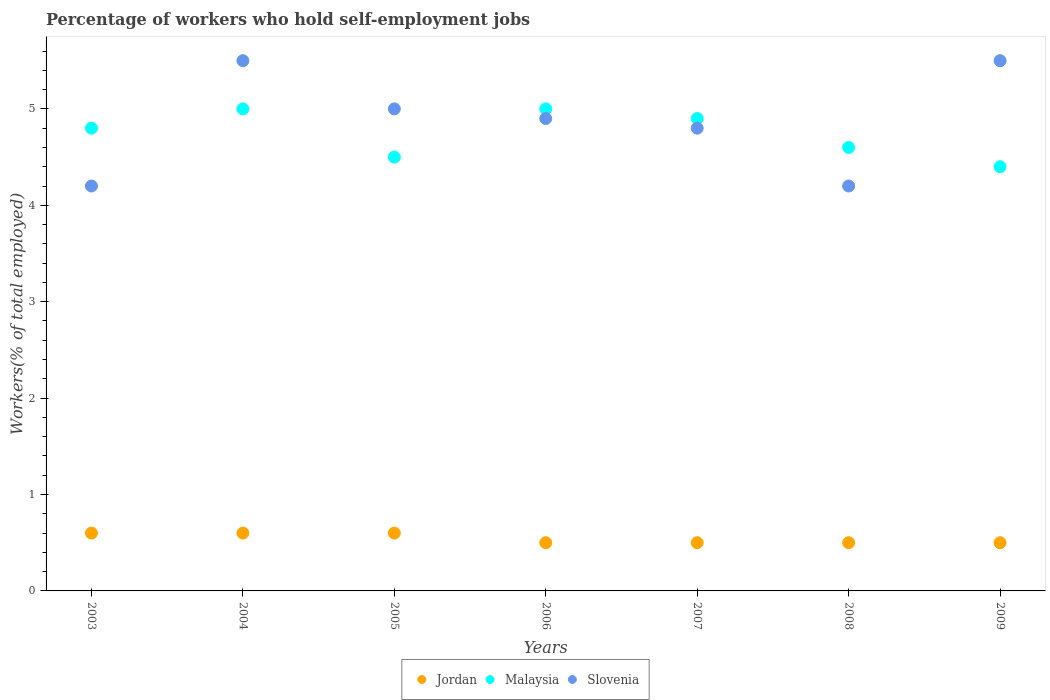How many different coloured dotlines are there?
Offer a very short reply. 3. Is the number of dotlines equal to the number of legend labels?
Offer a very short reply. Yes. What is the percentage of self-employed workers in Slovenia in 2007?
Give a very brief answer. 4.8. Across all years, what is the maximum percentage of self-employed workers in Malaysia?
Ensure brevity in your answer.  5. Across all years, what is the minimum percentage of self-employed workers in Jordan?
Keep it short and to the point. 0.5. In which year was the percentage of self-employed workers in Jordan maximum?
Give a very brief answer. 2003. In which year was the percentage of self-employed workers in Jordan minimum?
Ensure brevity in your answer.  2006. What is the total percentage of self-employed workers in Jordan in the graph?
Provide a short and direct response. 3.8. What is the difference between the percentage of self-employed workers in Slovenia in 2005 and that in 2008?
Offer a very short reply. 0.8. What is the average percentage of self-employed workers in Slovenia per year?
Ensure brevity in your answer.  4.87. In the year 2004, what is the difference between the percentage of self-employed workers in Slovenia and percentage of self-employed workers in Jordan?
Give a very brief answer. 4.9. What is the ratio of the percentage of self-employed workers in Slovenia in 2007 to that in 2009?
Offer a very short reply. 0.87. Is the difference between the percentage of self-employed workers in Slovenia in 2005 and 2009 greater than the difference between the percentage of self-employed workers in Jordan in 2005 and 2009?
Your answer should be compact. No. What is the difference between the highest and the lowest percentage of self-employed workers in Jordan?
Your response must be concise. 0.1. Is the sum of the percentage of self-employed workers in Jordan in 2003 and 2004 greater than the maximum percentage of self-employed workers in Malaysia across all years?
Give a very brief answer. No. Does the percentage of self-employed workers in Malaysia monotonically increase over the years?
Offer a very short reply. No. Is the percentage of self-employed workers in Malaysia strictly less than the percentage of self-employed workers in Jordan over the years?
Offer a terse response. No. How many years are there in the graph?
Offer a very short reply. 7. Does the graph contain grids?
Ensure brevity in your answer.  No. How are the legend labels stacked?
Offer a very short reply. Horizontal. What is the title of the graph?
Offer a terse response. Percentage of workers who hold self-employment jobs. What is the label or title of the Y-axis?
Make the answer very short. Workers(% of total employed). What is the Workers(% of total employed) in Jordan in 2003?
Keep it short and to the point. 0.6. What is the Workers(% of total employed) of Malaysia in 2003?
Give a very brief answer. 4.8. What is the Workers(% of total employed) of Slovenia in 2003?
Your response must be concise. 4.2. What is the Workers(% of total employed) of Jordan in 2004?
Ensure brevity in your answer.  0.6. What is the Workers(% of total employed) in Slovenia in 2004?
Your answer should be very brief. 5.5. What is the Workers(% of total employed) of Jordan in 2005?
Ensure brevity in your answer.  0.6. What is the Workers(% of total employed) in Malaysia in 2005?
Offer a terse response. 4.5. What is the Workers(% of total employed) in Jordan in 2006?
Provide a succinct answer. 0.5. What is the Workers(% of total employed) of Slovenia in 2006?
Make the answer very short. 4.9. What is the Workers(% of total employed) in Jordan in 2007?
Your response must be concise. 0.5. What is the Workers(% of total employed) in Malaysia in 2007?
Offer a terse response. 4.9. What is the Workers(% of total employed) in Slovenia in 2007?
Provide a succinct answer. 4.8. What is the Workers(% of total employed) in Jordan in 2008?
Make the answer very short. 0.5. What is the Workers(% of total employed) of Malaysia in 2008?
Ensure brevity in your answer.  4.6. What is the Workers(% of total employed) in Slovenia in 2008?
Offer a terse response. 4.2. What is the Workers(% of total employed) of Jordan in 2009?
Make the answer very short. 0.5. What is the Workers(% of total employed) in Malaysia in 2009?
Provide a short and direct response. 4.4. What is the Workers(% of total employed) of Slovenia in 2009?
Your answer should be compact. 5.5. Across all years, what is the maximum Workers(% of total employed) of Jordan?
Give a very brief answer. 0.6. Across all years, what is the maximum Workers(% of total employed) of Malaysia?
Your answer should be very brief. 5. Across all years, what is the minimum Workers(% of total employed) in Malaysia?
Provide a succinct answer. 4.4. Across all years, what is the minimum Workers(% of total employed) of Slovenia?
Your answer should be very brief. 4.2. What is the total Workers(% of total employed) of Jordan in the graph?
Provide a short and direct response. 3.8. What is the total Workers(% of total employed) in Malaysia in the graph?
Ensure brevity in your answer.  33.2. What is the total Workers(% of total employed) of Slovenia in the graph?
Offer a terse response. 34.1. What is the difference between the Workers(% of total employed) of Slovenia in 2003 and that in 2004?
Provide a succinct answer. -1.3. What is the difference between the Workers(% of total employed) of Malaysia in 2003 and that in 2005?
Your answer should be compact. 0.3. What is the difference between the Workers(% of total employed) of Slovenia in 2003 and that in 2005?
Provide a succinct answer. -0.8. What is the difference between the Workers(% of total employed) of Malaysia in 2003 and that in 2006?
Provide a short and direct response. -0.2. What is the difference between the Workers(% of total employed) in Malaysia in 2003 and that in 2007?
Keep it short and to the point. -0.1. What is the difference between the Workers(% of total employed) of Slovenia in 2003 and that in 2007?
Your answer should be compact. -0.6. What is the difference between the Workers(% of total employed) in Jordan in 2003 and that in 2008?
Offer a terse response. 0.1. What is the difference between the Workers(% of total employed) in Slovenia in 2003 and that in 2008?
Make the answer very short. 0. What is the difference between the Workers(% of total employed) in Jordan in 2003 and that in 2009?
Keep it short and to the point. 0.1. What is the difference between the Workers(% of total employed) of Jordan in 2004 and that in 2005?
Your response must be concise. 0. What is the difference between the Workers(% of total employed) of Malaysia in 2004 and that in 2005?
Offer a terse response. 0.5. What is the difference between the Workers(% of total employed) of Slovenia in 2004 and that in 2005?
Ensure brevity in your answer.  0.5. What is the difference between the Workers(% of total employed) of Jordan in 2004 and that in 2006?
Offer a terse response. 0.1. What is the difference between the Workers(% of total employed) of Slovenia in 2004 and that in 2006?
Ensure brevity in your answer.  0.6. What is the difference between the Workers(% of total employed) of Jordan in 2004 and that in 2007?
Provide a short and direct response. 0.1. What is the difference between the Workers(% of total employed) in Slovenia in 2004 and that in 2007?
Make the answer very short. 0.7. What is the difference between the Workers(% of total employed) in Jordan in 2004 and that in 2009?
Make the answer very short. 0.1. What is the difference between the Workers(% of total employed) in Malaysia in 2004 and that in 2009?
Ensure brevity in your answer.  0.6. What is the difference between the Workers(% of total employed) of Jordan in 2005 and that in 2006?
Offer a terse response. 0.1. What is the difference between the Workers(% of total employed) of Slovenia in 2005 and that in 2006?
Your answer should be compact. 0.1. What is the difference between the Workers(% of total employed) in Jordan in 2005 and that in 2008?
Offer a terse response. 0.1. What is the difference between the Workers(% of total employed) of Jordan in 2005 and that in 2009?
Offer a terse response. 0.1. What is the difference between the Workers(% of total employed) of Malaysia in 2005 and that in 2009?
Give a very brief answer. 0.1. What is the difference between the Workers(% of total employed) in Jordan in 2007 and that in 2008?
Offer a very short reply. 0. What is the difference between the Workers(% of total employed) of Jordan in 2007 and that in 2009?
Your response must be concise. 0. What is the difference between the Workers(% of total employed) in Slovenia in 2007 and that in 2009?
Provide a short and direct response. -0.7. What is the difference between the Workers(% of total employed) of Malaysia in 2008 and that in 2009?
Provide a short and direct response. 0.2. What is the difference between the Workers(% of total employed) in Jordan in 2003 and the Workers(% of total employed) in Malaysia in 2004?
Provide a short and direct response. -4.4. What is the difference between the Workers(% of total employed) of Jordan in 2003 and the Workers(% of total employed) of Malaysia in 2005?
Offer a very short reply. -3.9. What is the difference between the Workers(% of total employed) in Jordan in 2003 and the Workers(% of total employed) in Slovenia in 2006?
Ensure brevity in your answer.  -4.3. What is the difference between the Workers(% of total employed) of Malaysia in 2003 and the Workers(% of total employed) of Slovenia in 2006?
Provide a short and direct response. -0.1. What is the difference between the Workers(% of total employed) in Jordan in 2003 and the Workers(% of total employed) in Malaysia in 2007?
Offer a very short reply. -4.3. What is the difference between the Workers(% of total employed) of Jordan in 2003 and the Workers(% of total employed) of Malaysia in 2008?
Offer a very short reply. -4. What is the difference between the Workers(% of total employed) in Jordan in 2003 and the Workers(% of total employed) in Slovenia in 2008?
Keep it short and to the point. -3.6. What is the difference between the Workers(% of total employed) in Malaysia in 2003 and the Workers(% of total employed) in Slovenia in 2008?
Provide a short and direct response. 0.6. What is the difference between the Workers(% of total employed) of Jordan in 2003 and the Workers(% of total employed) of Malaysia in 2009?
Make the answer very short. -3.8. What is the difference between the Workers(% of total employed) of Jordan in 2004 and the Workers(% of total employed) of Malaysia in 2005?
Make the answer very short. -3.9. What is the difference between the Workers(% of total employed) in Jordan in 2004 and the Workers(% of total employed) in Slovenia in 2005?
Your response must be concise. -4.4. What is the difference between the Workers(% of total employed) of Malaysia in 2004 and the Workers(% of total employed) of Slovenia in 2005?
Your response must be concise. 0. What is the difference between the Workers(% of total employed) in Jordan in 2004 and the Workers(% of total employed) in Malaysia in 2007?
Give a very brief answer. -4.3. What is the difference between the Workers(% of total employed) of Jordan in 2004 and the Workers(% of total employed) of Slovenia in 2007?
Your response must be concise. -4.2. What is the difference between the Workers(% of total employed) in Jordan in 2004 and the Workers(% of total employed) in Malaysia in 2008?
Make the answer very short. -4. What is the difference between the Workers(% of total employed) in Malaysia in 2004 and the Workers(% of total employed) in Slovenia in 2008?
Your answer should be compact. 0.8. What is the difference between the Workers(% of total employed) of Jordan in 2004 and the Workers(% of total employed) of Malaysia in 2009?
Provide a succinct answer. -3.8. What is the difference between the Workers(% of total employed) in Jordan in 2005 and the Workers(% of total employed) in Malaysia in 2006?
Your answer should be very brief. -4.4. What is the difference between the Workers(% of total employed) in Jordan in 2005 and the Workers(% of total employed) in Slovenia in 2006?
Keep it short and to the point. -4.3. What is the difference between the Workers(% of total employed) in Malaysia in 2005 and the Workers(% of total employed) in Slovenia in 2007?
Your response must be concise. -0.3. What is the difference between the Workers(% of total employed) in Jordan in 2005 and the Workers(% of total employed) in Slovenia in 2008?
Offer a very short reply. -3.6. What is the difference between the Workers(% of total employed) in Jordan in 2005 and the Workers(% of total employed) in Slovenia in 2009?
Provide a short and direct response. -4.9. What is the difference between the Workers(% of total employed) in Malaysia in 2005 and the Workers(% of total employed) in Slovenia in 2009?
Your response must be concise. -1. What is the difference between the Workers(% of total employed) in Jordan in 2006 and the Workers(% of total employed) in Malaysia in 2007?
Give a very brief answer. -4.4. What is the difference between the Workers(% of total employed) of Jordan in 2006 and the Workers(% of total employed) of Slovenia in 2007?
Keep it short and to the point. -4.3. What is the difference between the Workers(% of total employed) in Jordan in 2006 and the Workers(% of total employed) in Slovenia in 2008?
Give a very brief answer. -3.7. What is the difference between the Workers(% of total employed) in Malaysia in 2006 and the Workers(% of total employed) in Slovenia in 2008?
Your response must be concise. 0.8. What is the difference between the Workers(% of total employed) of Jordan in 2006 and the Workers(% of total employed) of Malaysia in 2009?
Offer a very short reply. -3.9. What is the difference between the Workers(% of total employed) of Jordan in 2006 and the Workers(% of total employed) of Slovenia in 2009?
Provide a succinct answer. -5. What is the difference between the Workers(% of total employed) of Jordan in 2007 and the Workers(% of total employed) of Malaysia in 2008?
Provide a short and direct response. -4.1. What is the difference between the Workers(% of total employed) of Malaysia in 2007 and the Workers(% of total employed) of Slovenia in 2008?
Offer a very short reply. 0.7. What is the difference between the Workers(% of total employed) in Jordan in 2007 and the Workers(% of total employed) in Malaysia in 2009?
Your answer should be compact. -3.9. What is the difference between the Workers(% of total employed) in Malaysia in 2007 and the Workers(% of total employed) in Slovenia in 2009?
Give a very brief answer. -0.6. What is the difference between the Workers(% of total employed) of Jordan in 2008 and the Workers(% of total employed) of Malaysia in 2009?
Ensure brevity in your answer.  -3.9. What is the difference between the Workers(% of total employed) of Malaysia in 2008 and the Workers(% of total employed) of Slovenia in 2009?
Keep it short and to the point. -0.9. What is the average Workers(% of total employed) of Jordan per year?
Your response must be concise. 0.54. What is the average Workers(% of total employed) of Malaysia per year?
Offer a very short reply. 4.74. What is the average Workers(% of total employed) in Slovenia per year?
Ensure brevity in your answer.  4.87. In the year 2003, what is the difference between the Workers(% of total employed) of Jordan and Workers(% of total employed) of Slovenia?
Keep it short and to the point. -3.6. In the year 2004, what is the difference between the Workers(% of total employed) of Malaysia and Workers(% of total employed) of Slovenia?
Offer a very short reply. -0.5. In the year 2005, what is the difference between the Workers(% of total employed) of Jordan and Workers(% of total employed) of Malaysia?
Keep it short and to the point. -3.9. In the year 2005, what is the difference between the Workers(% of total employed) in Jordan and Workers(% of total employed) in Slovenia?
Offer a very short reply. -4.4. In the year 2005, what is the difference between the Workers(% of total employed) of Malaysia and Workers(% of total employed) of Slovenia?
Keep it short and to the point. -0.5. In the year 2006, what is the difference between the Workers(% of total employed) of Malaysia and Workers(% of total employed) of Slovenia?
Your answer should be very brief. 0.1. In the year 2007, what is the difference between the Workers(% of total employed) in Jordan and Workers(% of total employed) in Malaysia?
Provide a succinct answer. -4.4. In the year 2007, what is the difference between the Workers(% of total employed) in Malaysia and Workers(% of total employed) in Slovenia?
Your response must be concise. 0.1. In the year 2008, what is the difference between the Workers(% of total employed) in Jordan and Workers(% of total employed) in Malaysia?
Your response must be concise. -4.1. In the year 2009, what is the difference between the Workers(% of total employed) of Jordan and Workers(% of total employed) of Malaysia?
Give a very brief answer. -3.9. In the year 2009, what is the difference between the Workers(% of total employed) of Malaysia and Workers(% of total employed) of Slovenia?
Offer a terse response. -1.1. What is the ratio of the Workers(% of total employed) of Jordan in 2003 to that in 2004?
Your answer should be compact. 1. What is the ratio of the Workers(% of total employed) of Slovenia in 2003 to that in 2004?
Give a very brief answer. 0.76. What is the ratio of the Workers(% of total employed) of Malaysia in 2003 to that in 2005?
Offer a terse response. 1.07. What is the ratio of the Workers(% of total employed) of Slovenia in 2003 to that in 2005?
Give a very brief answer. 0.84. What is the ratio of the Workers(% of total employed) of Jordan in 2003 to that in 2006?
Offer a very short reply. 1.2. What is the ratio of the Workers(% of total employed) in Malaysia in 2003 to that in 2006?
Your answer should be very brief. 0.96. What is the ratio of the Workers(% of total employed) of Jordan in 2003 to that in 2007?
Give a very brief answer. 1.2. What is the ratio of the Workers(% of total employed) of Malaysia in 2003 to that in 2007?
Make the answer very short. 0.98. What is the ratio of the Workers(% of total employed) of Slovenia in 2003 to that in 2007?
Ensure brevity in your answer.  0.88. What is the ratio of the Workers(% of total employed) in Jordan in 2003 to that in 2008?
Give a very brief answer. 1.2. What is the ratio of the Workers(% of total employed) in Malaysia in 2003 to that in 2008?
Keep it short and to the point. 1.04. What is the ratio of the Workers(% of total employed) in Slovenia in 2003 to that in 2008?
Offer a terse response. 1. What is the ratio of the Workers(% of total employed) in Jordan in 2003 to that in 2009?
Ensure brevity in your answer.  1.2. What is the ratio of the Workers(% of total employed) of Malaysia in 2003 to that in 2009?
Your answer should be compact. 1.09. What is the ratio of the Workers(% of total employed) in Slovenia in 2003 to that in 2009?
Make the answer very short. 0.76. What is the ratio of the Workers(% of total employed) in Jordan in 2004 to that in 2005?
Your answer should be very brief. 1. What is the ratio of the Workers(% of total employed) of Slovenia in 2004 to that in 2005?
Your answer should be very brief. 1.1. What is the ratio of the Workers(% of total employed) in Jordan in 2004 to that in 2006?
Ensure brevity in your answer.  1.2. What is the ratio of the Workers(% of total employed) in Slovenia in 2004 to that in 2006?
Your response must be concise. 1.12. What is the ratio of the Workers(% of total employed) in Malaysia in 2004 to that in 2007?
Provide a succinct answer. 1.02. What is the ratio of the Workers(% of total employed) in Slovenia in 2004 to that in 2007?
Offer a terse response. 1.15. What is the ratio of the Workers(% of total employed) in Jordan in 2004 to that in 2008?
Ensure brevity in your answer.  1.2. What is the ratio of the Workers(% of total employed) of Malaysia in 2004 to that in 2008?
Your response must be concise. 1.09. What is the ratio of the Workers(% of total employed) in Slovenia in 2004 to that in 2008?
Make the answer very short. 1.31. What is the ratio of the Workers(% of total employed) in Jordan in 2004 to that in 2009?
Provide a short and direct response. 1.2. What is the ratio of the Workers(% of total employed) of Malaysia in 2004 to that in 2009?
Keep it short and to the point. 1.14. What is the ratio of the Workers(% of total employed) in Slovenia in 2005 to that in 2006?
Give a very brief answer. 1.02. What is the ratio of the Workers(% of total employed) of Malaysia in 2005 to that in 2007?
Your response must be concise. 0.92. What is the ratio of the Workers(% of total employed) in Slovenia in 2005 to that in 2007?
Your answer should be very brief. 1.04. What is the ratio of the Workers(% of total employed) in Jordan in 2005 to that in 2008?
Offer a terse response. 1.2. What is the ratio of the Workers(% of total employed) in Malaysia in 2005 to that in 2008?
Offer a very short reply. 0.98. What is the ratio of the Workers(% of total employed) of Slovenia in 2005 to that in 2008?
Offer a terse response. 1.19. What is the ratio of the Workers(% of total employed) in Jordan in 2005 to that in 2009?
Your answer should be very brief. 1.2. What is the ratio of the Workers(% of total employed) in Malaysia in 2005 to that in 2009?
Provide a short and direct response. 1.02. What is the ratio of the Workers(% of total employed) of Jordan in 2006 to that in 2007?
Keep it short and to the point. 1. What is the ratio of the Workers(% of total employed) in Malaysia in 2006 to that in 2007?
Your answer should be very brief. 1.02. What is the ratio of the Workers(% of total employed) of Slovenia in 2006 to that in 2007?
Offer a very short reply. 1.02. What is the ratio of the Workers(% of total employed) in Malaysia in 2006 to that in 2008?
Your answer should be very brief. 1.09. What is the ratio of the Workers(% of total employed) in Malaysia in 2006 to that in 2009?
Your answer should be compact. 1.14. What is the ratio of the Workers(% of total employed) in Slovenia in 2006 to that in 2009?
Give a very brief answer. 0.89. What is the ratio of the Workers(% of total employed) in Jordan in 2007 to that in 2008?
Ensure brevity in your answer.  1. What is the ratio of the Workers(% of total employed) in Malaysia in 2007 to that in 2008?
Offer a terse response. 1.07. What is the ratio of the Workers(% of total employed) in Jordan in 2007 to that in 2009?
Provide a short and direct response. 1. What is the ratio of the Workers(% of total employed) in Malaysia in 2007 to that in 2009?
Offer a terse response. 1.11. What is the ratio of the Workers(% of total employed) of Slovenia in 2007 to that in 2009?
Provide a succinct answer. 0.87. What is the ratio of the Workers(% of total employed) of Jordan in 2008 to that in 2009?
Your answer should be very brief. 1. What is the ratio of the Workers(% of total employed) in Malaysia in 2008 to that in 2009?
Your answer should be very brief. 1.05. What is the ratio of the Workers(% of total employed) of Slovenia in 2008 to that in 2009?
Your response must be concise. 0.76. What is the difference between the highest and the second highest Workers(% of total employed) in Jordan?
Keep it short and to the point. 0. What is the difference between the highest and the second highest Workers(% of total employed) in Malaysia?
Your answer should be compact. 0. What is the difference between the highest and the second highest Workers(% of total employed) in Slovenia?
Offer a very short reply. 0. What is the difference between the highest and the lowest Workers(% of total employed) of Jordan?
Make the answer very short. 0.1. 